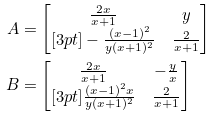<formula> <loc_0><loc_0><loc_500><loc_500>A & = \begin{bmatrix} \frac { 2 x } { x + 1 } & y \\ [ 3 p t ] - \frac { ( x - 1 ) ^ { 2 } } { y ( x + 1 ) ^ { 2 } } & \frac { 2 } { x + 1 } \end{bmatrix} \\ B & = \begin{bmatrix} \frac { 2 x } { x + 1 } & - \frac { y } { x } \\ [ 3 p t ] \frac { ( x - 1 ) ^ { 2 } x } { y ( x + 1 ) ^ { 2 } } & \frac { 2 } { x + 1 } \end{bmatrix}</formula> 